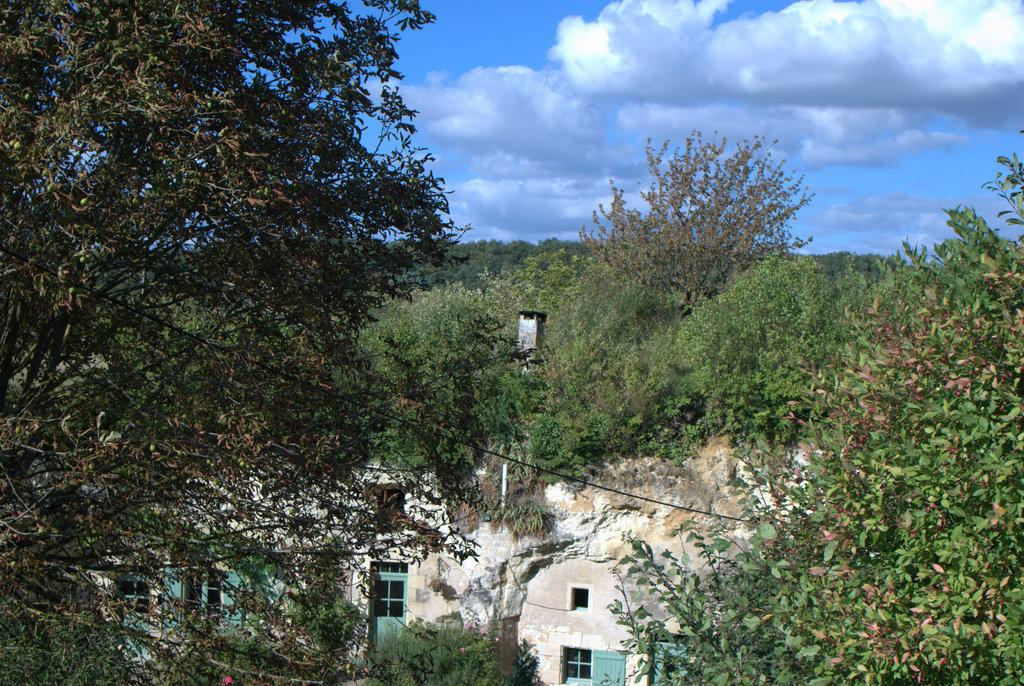What type of vegetation can be seen in the image? There are trees in the image. What type of structure is present in the image? There is a building in the image. What is visible in the background of the image? The sky is visible in the image. What type of cast can be seen on the tree in the image? There is no cast present on any tree in the image; only trees, a building, and the sky are visible. How does the sleet affect the appearance of the building in the image? There is no sleet present in the image; it only features trees, a building, and the sky. 